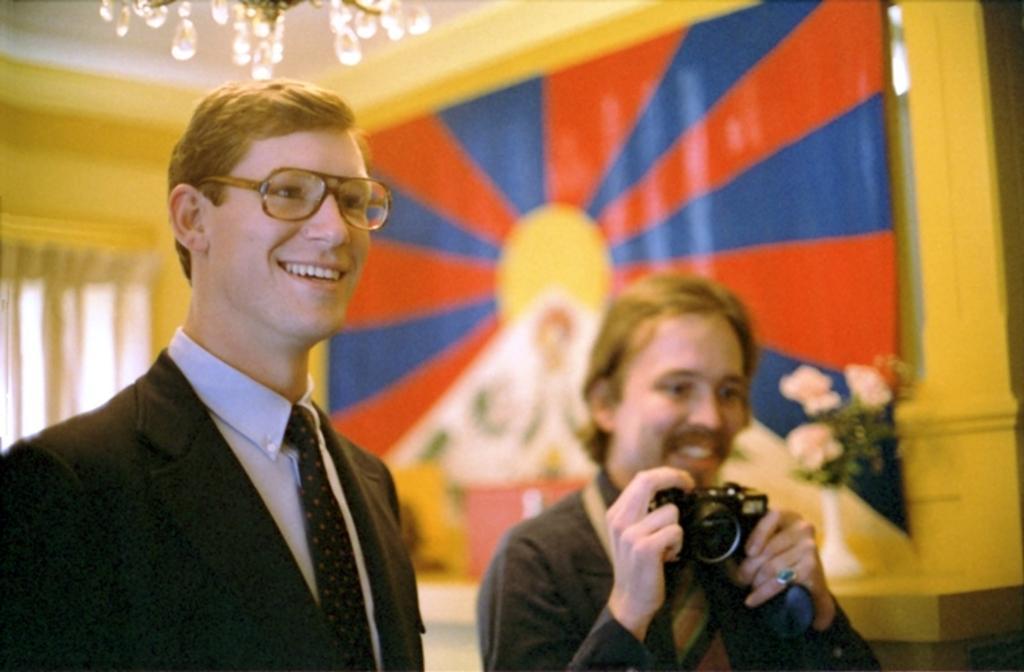How would you summarize this image in a sentence or two? In this image I see 2 men and both of them are smiling. I can also see that this man is holding the camera. In the background I see a flower vase, the wall, a curtain and the lights. 